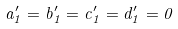<formula> <loc_0><loc_0><loc_500><loc_500>a ^ { \prime } _ { 1 } = b ^ { \prime } _ { 1 } = c ^ { \prime } _ { 1 } = d ^ { \prime } _ { 1 } = 0</formula> 